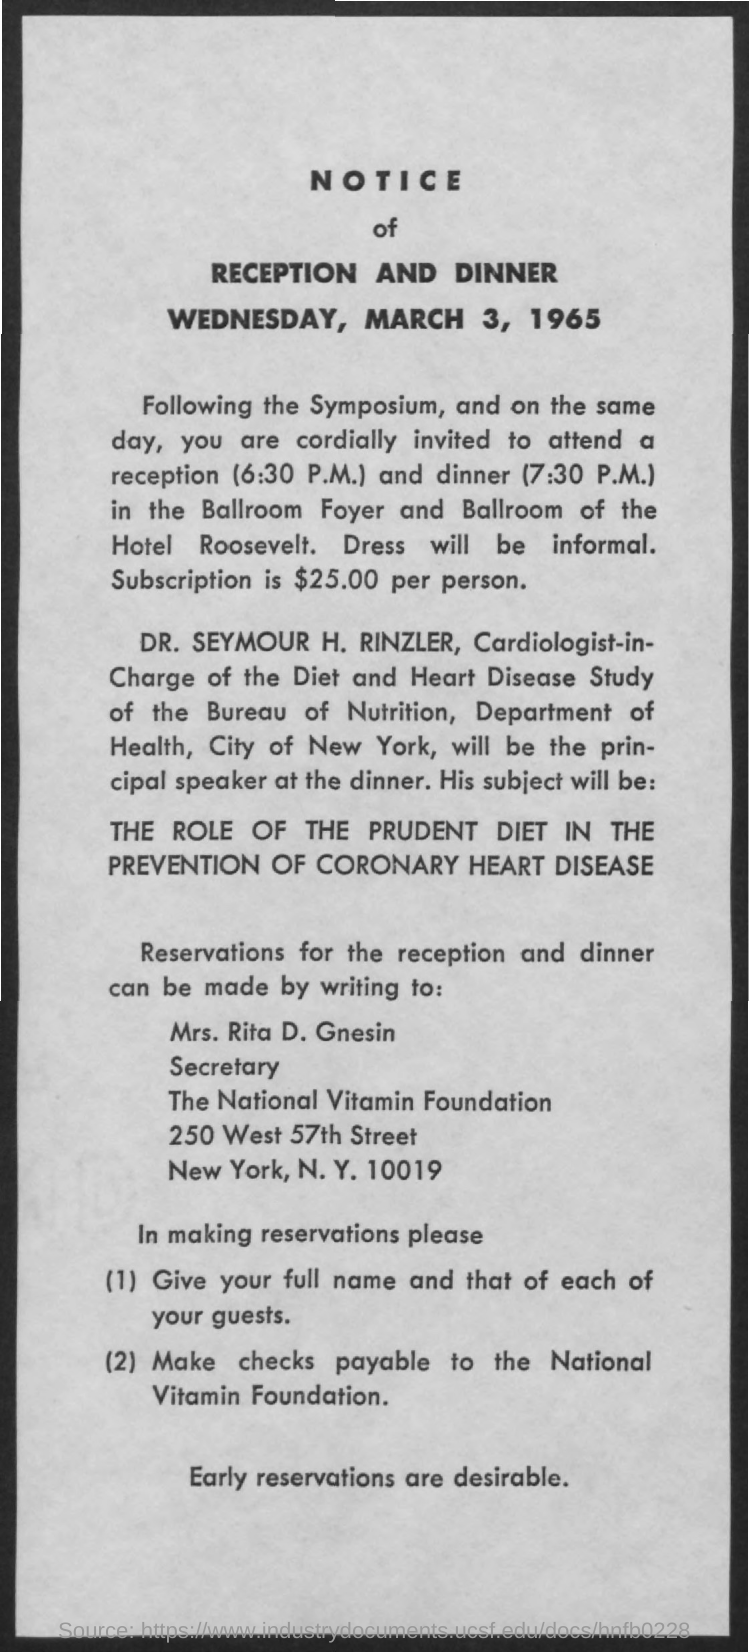Outline some significant characteristics in this image. The role of diet, specifically the Prudent Diet, in the prevention of coronary heart disease has been established. It is currently 7:30 P.M. and dinner will be served shortly. Please make checks payable to the National Vitamin Foundation. The reception and dinner will take place on Wednesday, March 3, 1965. It is possible to make reservations for the reception and dinner by contacting Mrs. Rita D. Gnesin. 